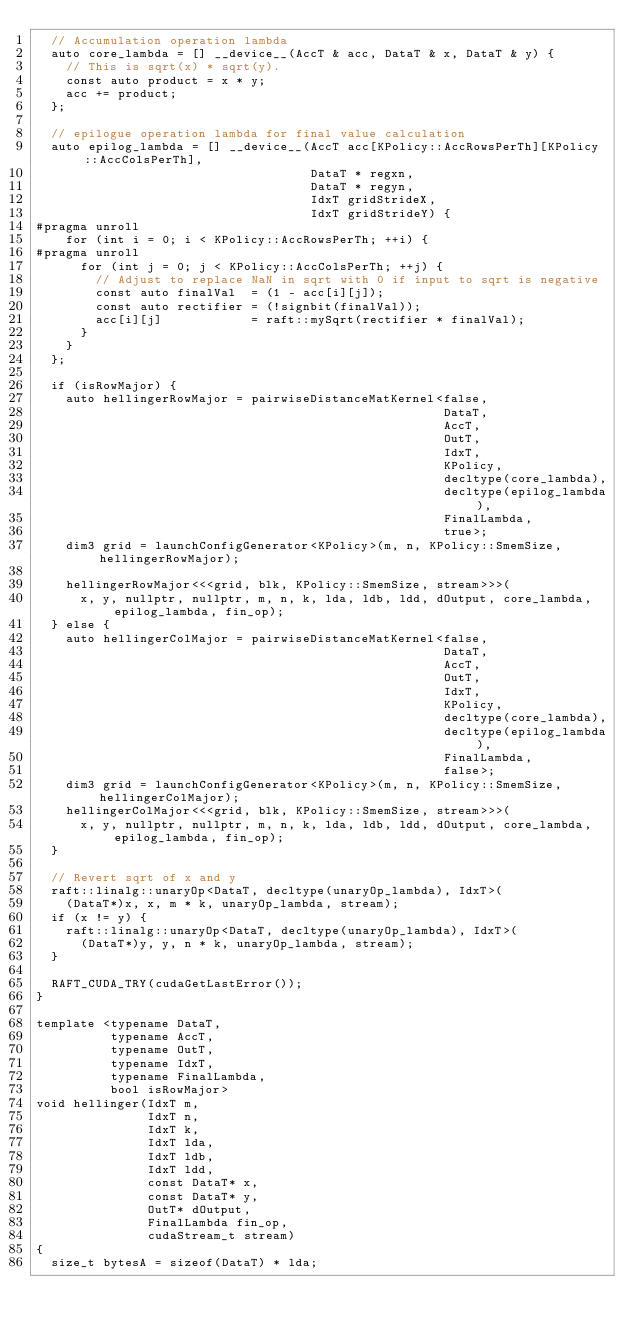Convert code to text. <code><loc_0><loc_0><loc_500><loc_500><_Cuda_>  // Accumulation operation lambda
  auto core_lambda = [] __device__(AccT & acc, DataT & x, DataT & y) {
    // This is sqrt(x) * sqrt(y).
    const auto product = x * y;
    acc += product;
  };

  // epilogue operation lambda for final value calculation
  auto epilog_lambda = [] __device__(AccT acc[KPolicy::AccRowsPerTh][KPolicy::AccColsPerTh],
                                     DataT * regxn,
                                     DataT * regyn,
                                     IdxT gridStrideX,
                                     IdxT gridStrideY) {
#pragma unroll
    for (int i = 0; i < KPolicy::AccRowsPerTh; ++i) {
#pragma unroll
      for (int j = 0; j < KPolicy::AccColsPerTh; ++j) {
        // Adjust to replace NaN in sqrt with 0 if input to sqrt is negative
        const auto finalVal  = (1 - acc[i][j]);
        const auto rectifier = (!signbit(finalVal));
        acc[i][j]            = raft::mySqrt(rectifier * finalVal);
      }
    }
  };

  if (isRowMajor) {
    auto hellingerRowMajor = pairwiseDistanceMatKernel<false,
                                                       DataT,
                                                       AccT,
                                                       OutT,
                                                       IdxT,
                                                       KPolicy,
                                                       decltype(core_lambda),
                                                       decltype(epilog_lambda),
                                                       FinalLambda,
                                                       true>;
    dim3 grid = launchConfigGenerator<KPolicy>(m, n, KPolicy::SmemSize, hellingerRowMajor);

    hellingerRowMajor<<<grid, blk, KPolicy::SmemSize, stream>>>(
      x, y, nullptr, nullptr, m, n, k, lda, ldb, ldd, dOutput, core_lambda, epilog_lambda, fin_op);
  } else {
    auto hellingerColMajor = pairwiseDistanceMatKernel<false,
                                                       DataT,
                                                       AccT,
                                                       OutT,
                                                       IdxT,
                                                       KPolicy,
                                                       decltype(core_lambda),
                                                       decltype(epilog_lambda),
                                                       FinalLambda,
                                                       false>;
    dim3 grid = launchConfigGenerator<KPolicy>(m, n, KPolicy::SmemSize, hellingerColMajor);
    hellingerColMajor<<<grid, blk, KPolicy::SmemSize, stream>>>(
      x, y, nullptr, nullptr, m, n, k, lda, ldb, ldd, dOutput, core_lambda, epilog_lambda, fin_op);
  }

  // Revert sqrt of x and y
  raft::linalg::unaryOp<DataT, decltype(unaryOp_lambda), IdxT>(
    (DataT*)x, x, m * k, unaryOp_lambda, stream);
  if (x != y) {
    raft::linalg::unaryOp<DataT, decltype(unaryOp_lambda), IdxT>(
      (DataT*)y, y, n * k, unaryOp_lambda, stream);
  }

  RAFT_CUDA_TRY(cudaGetLastError());
}

template <typename DataT,
          typename AccT,
          typename OutT,
          typename IdxT,
          typename FinalLambda,
          bool isRowMajor>
void hellinger(IdxT m,
               IdxT n,
               IdxT k,
               IdxT lda,
               IdxT ldb,
               IdxT ldd,
               const DataT* x,
               const DataT* y,
               OutT* dOutput,
               FinalLambda fin_op,
               cudaStream_t stream)
{
  size_t bytesA = sizeof(DataT) * lda;</code> 